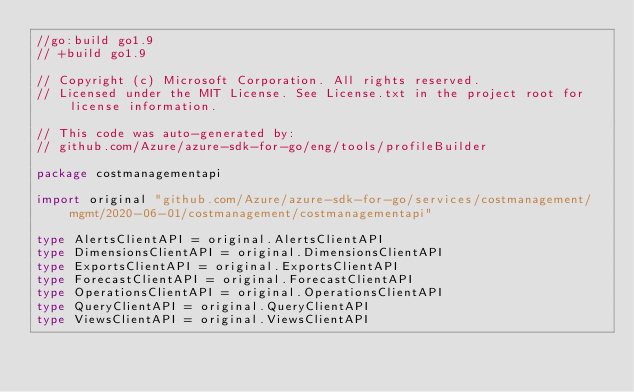<code> <loc_0><loc_0><loc_500><loc_500><_Go_>//go:build go1.9
// +build go1.9

// Copyright (c) Microsoft Corporation. All rights reserved.
// Licensed under the MIT License. See License.txt in the project root for license information.

// This code was auto-generated by:
// github.com/Azure/azure-sdk-for-go/eng/tools/profileBuilder

package costmanagementapi

import original "github.com/Azure/azure-sdk-for-go/services/costmanagement/mgmt/2020-06-01/costmanagement/costmanagementapi"

type AlertsClientAPI = original.AlertsClientAPI
type DimensionsClientAPI = original.DimensionsClientAPI
type ExportsClientAPI = original.ExportsClientAPI
type ForecastClientAPI = original.ForecastClientAPI
type OperationsClientAPI = original.OperationsClientAPI
type QueryClientAPI = original.QueryClientAPI
type ViewsClientAPI = original.ViewsClientAPI
</code> 